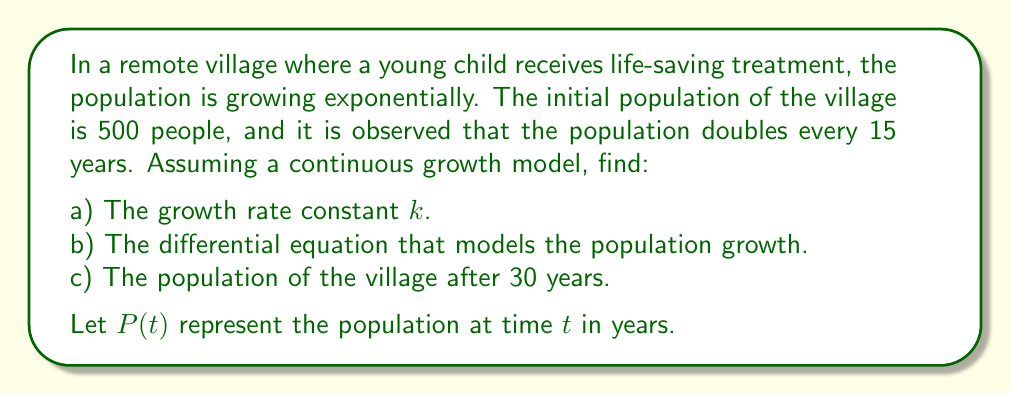What is the answer to this math problem? Let's approach this problem step by step:

a) To find the growth rate constant $k$:
   We know that the population doubles every 15 years. Using the exponential growth formula:
   
   $$P(t) = P_0 e^{kt}$$
   
   Where $P_0$ is the initial population, we can write:
   
   $$2P_0 = P_0 e^{k(15)}$$
   
   Simplifying:
   
   $$2 = e^{15k}$$
   
   Taking natural logarithm of both sides:
   
   $$\ln(2) = 15k$$
   
   $$k = \frac{\ln(2)}{15} \approx 0.0462$$

b) The differential equation modeling the population growth:
   The general form of the differential equation for exponential growth is:
   
   $$\frac{dP}{dt} = kP$$
   
   Substituting our value of $k$:
   
   $$\frac{dP}{dt} = 0.0462P$$

c) To find the population after 30 years:
   We use the exponential growth formula with $t = 30$, $P_0 = 500$, and $k = 0.0462$:
   
   $$P(30) = 500 e^{0.0462(30)}$$
   
   $$P(30) = 500 e^{1.386}$$
   
   $$P(30) = 500 (4) = 2000$$
Answer: a) $k \approx 0.0462$ year$^{-1}$
b) $\frac{dP}{dt} = 0.0462P$
c) 2000 people 